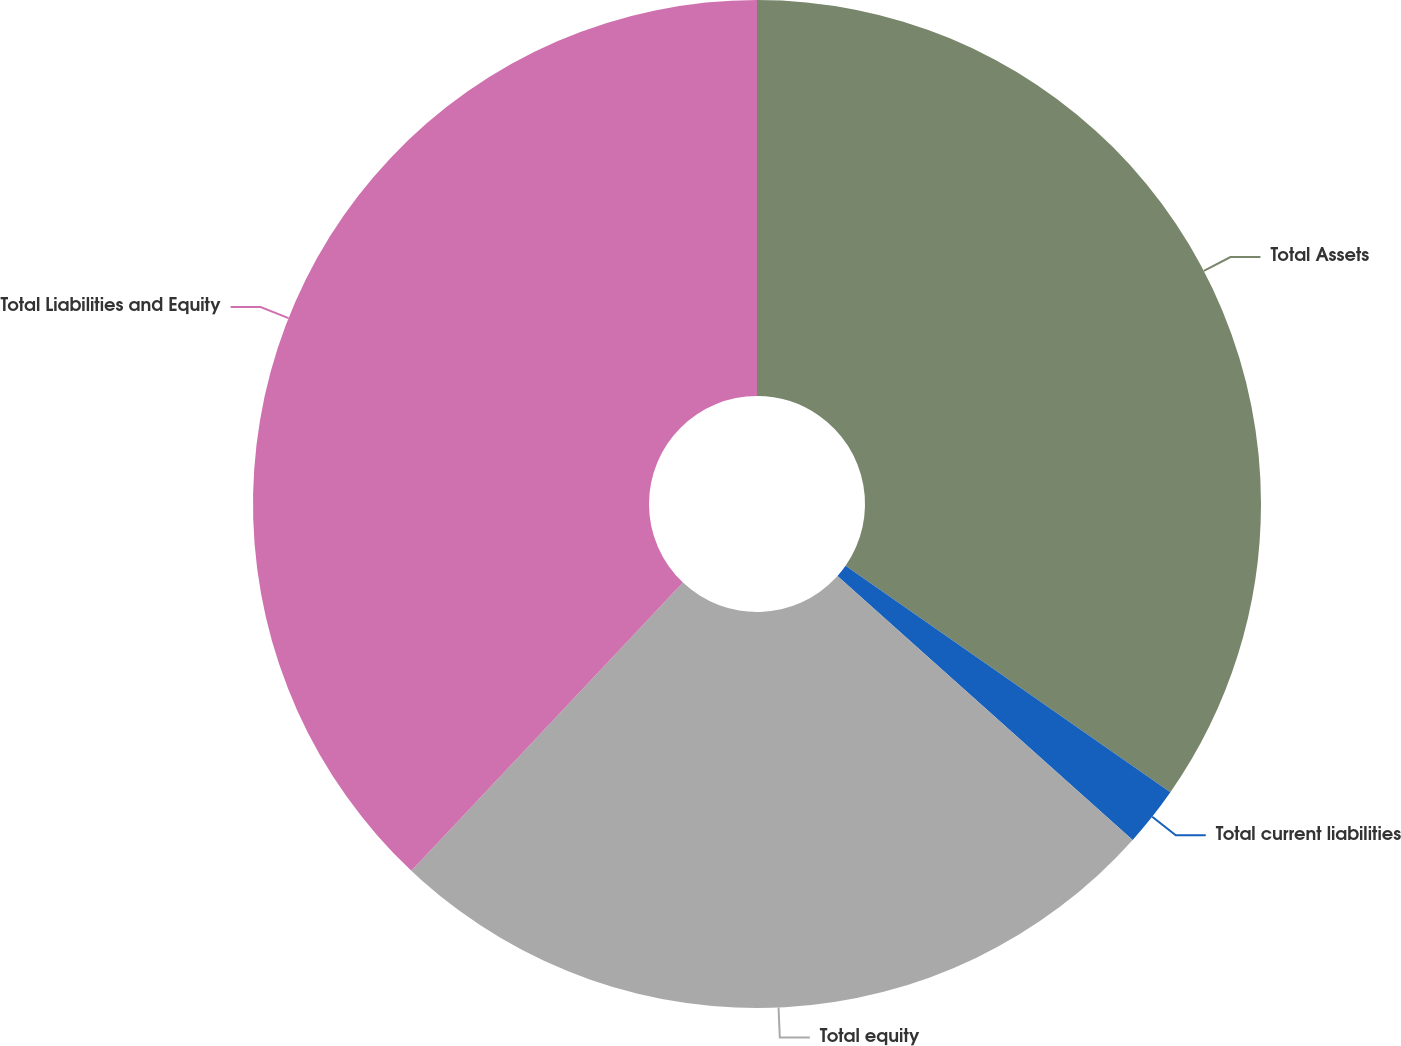<chart> <loc_0><loc_0><loc_500><loc_500><pie_chart><fcel>Total Assets<fcel>Total current liabilities<fcel>Total equity<fcel>Total Liabilities and Equity<nl><fcel>34.69%<fcel>1.92%<fcel>25.41%<fcel>37.97%<nl></chart> 